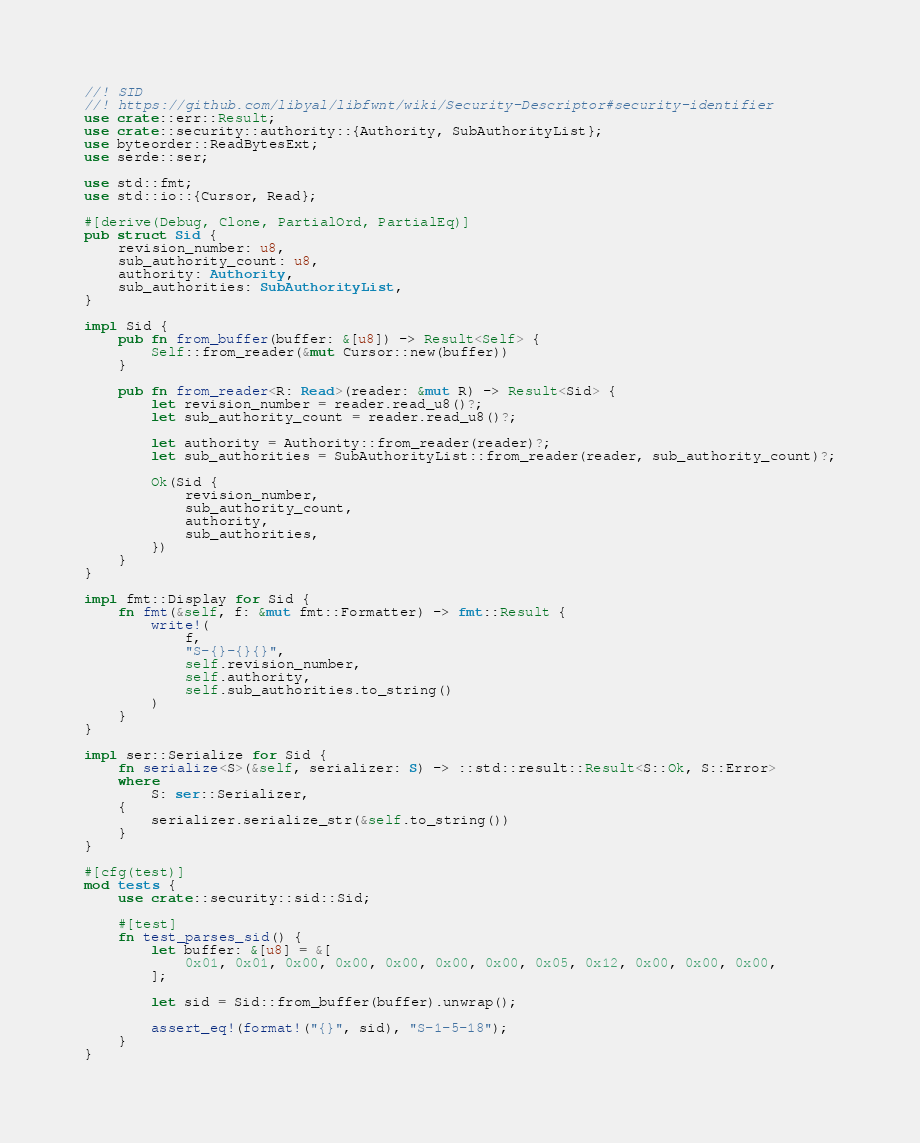Convert code to text. <code><loc_0><loc_0><loc_500><loc_500><_Rust_>//! SID
//! https://github.com/libyal/libfwnt/wiki/Security-Descriptor#security-identifier
use crate::err::Result;
use crate::security::authority::{Authority, SubAuthorityList};
use byteorder::ReadBytesExt;
use serde::ser;

use std::fmt;
use std::io::{Cursor, Read};

#[derive(Debug, Clone, PartialOrd, PartialEq)]
pub struct Sid {
    revision_number: u8,
    sub_authority_count: u8,
    authority: Authority,
    sub_authorities: SubAuthorityList,
}

impl Sid {
    pub fn from_buffer(buffer: &[u8]) -> Result<Self> {
        Self::from_reader(&mut Cursor::new(buffer))
    }

    pub fn from_reader<R: Read>(reader: &mut R) -> Result<Sid> {
        let revision_number = reader.read_u8()?;
        let sub_authority_count = reader.read_u8()?;

        let authority = Authority::from_reader(reader)?;
        let sub_authorities = SubAuthorityList::from_reader(reader, sub_authority_count)?;

        Ok(Sid {
            revision_number,
            sub_authority_count,
            authority,
            sub_authorities,
        })
    }
}

impl fmt::Display for Sid {
    fn fmt(&self, f: &mut fmt::Formatter) -> fmt::Result {
        write!(
            f,
            "S-{}-{}{}",
            self.revision_number,
            self.authority,
            self.sub_authorities.to_string()
        )
    }
}

impl ser::Serialize for Sid {
    fn serialize<S>(&self, serializer: S) -> ::std::result::Result<S::Ok, S::Error>
    where
        S: ser::Serializer,
    {
        serializer.serialize_str(&self.to_string())
    }
}

#[cfg(test)]
mod tests {
    use crate::security::sid::Sid;

    #[test]
    fn test_parses_sid() {
        let buffer: &[u8] = &[
            0x01, 0x01, 0x00, 0x00, 0x00, 0x00, 0x00, 0x05, 0x12, 0x00, 0x00, 0x00,
        ];

        let sid = Sid::from_buffer(buffer).unwrap();

        assert_eq!(format!("{}", sid), "S-1-5-18");
    }
}
</code> 